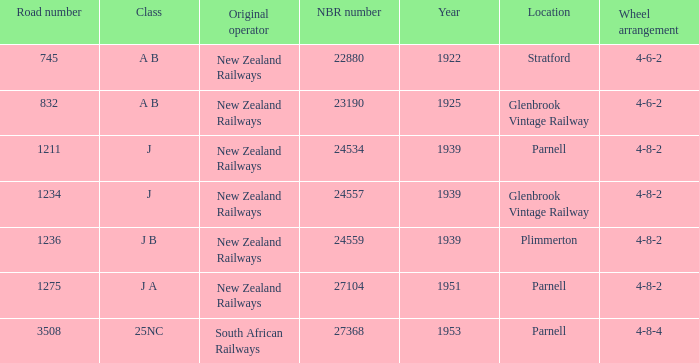Which class starts after 1939 and has a road number smaller than 3508? J A. 